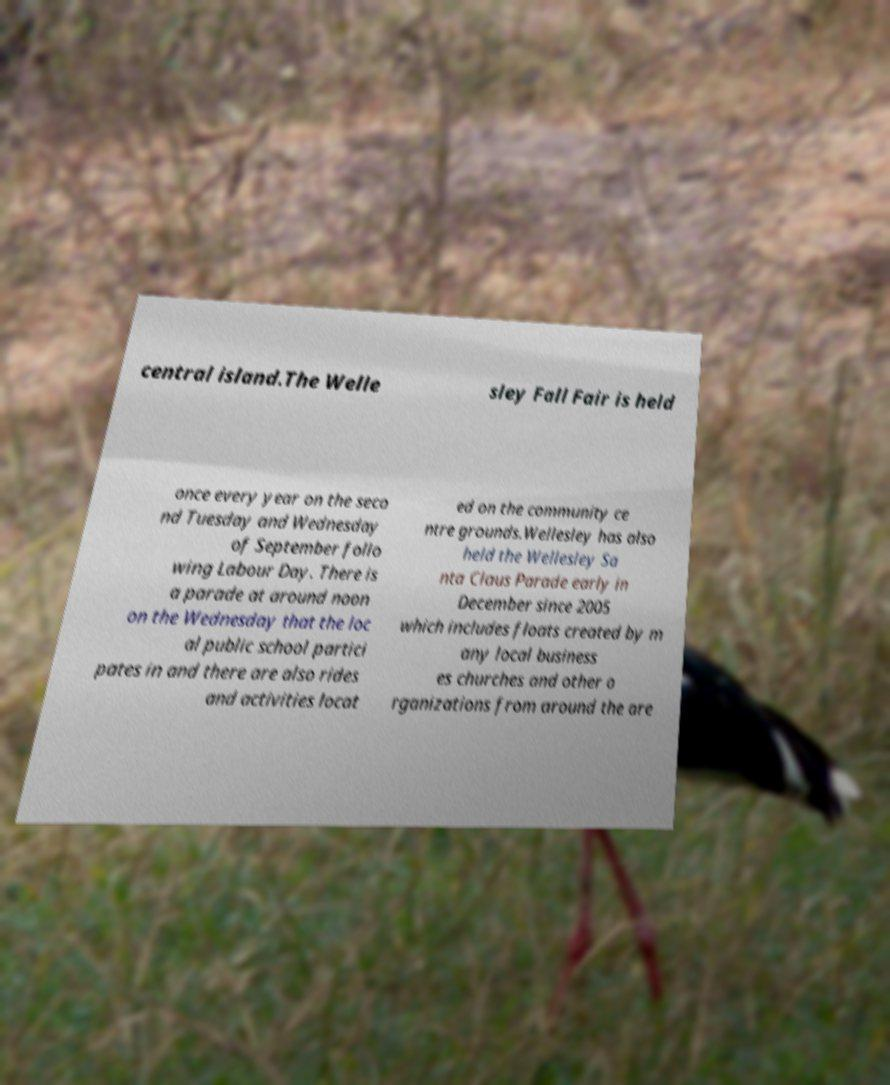There's text embedded in this image that I need extracted. Can you transcribe it verbatim? central island.The Welle sley Fall Fair is held once every year on the seco nd Tuesday and Wednesday of September follo wing Labour Day. There is a parade at around noon on the Wednesday that the loc al public school partici pates in and there are also rides and activities locat ed on the community ce ntre grounds.Wellesley has also held the Wellesley Sa nta Claus Parade early in December since 2005 which includes floats created by m any local business es churches and other o rganizations from around the are 